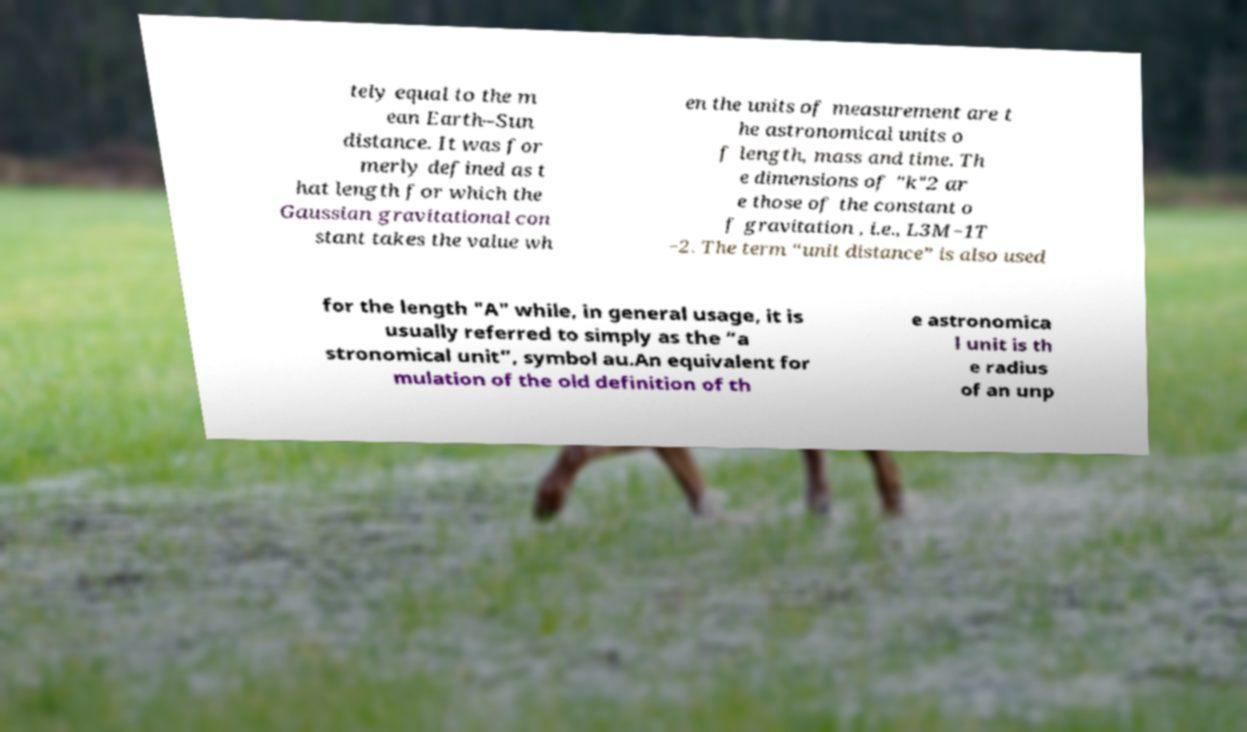Please identify and transcribe the text found in this image. tely equal to the m ean Earth–Sun distance. It was for merly defined as t hat length for which the Gaussian gravitational con stant takes the value wh en the units of measurement are t he astronomical units o f length, mass and time. Th e dimensions of "k"2 ar e those of the constant o f gravitation , i.e., L3M−1T −2. The term “unit distance” is also used for the length "A" while, in general usage, it is usually referred to simply as the “a stronomical unit”, symbol au.An equivalent for mulation of the old definition of th e astronomica l unit is th e radius of an unp 